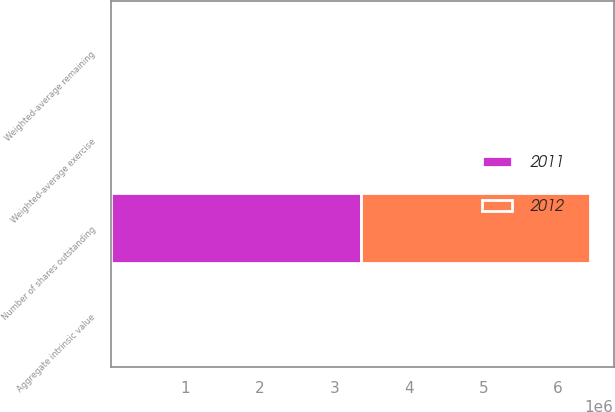Convert chart. <chart><loc_0><loc_0><loc_500><loc_500><stacked_bar_chart><ecel><fcel>Number of shares outstanding<fcel>Weighted-average exercise<fcel>Weighted-average remaining<fcel>Aggregate intrinsic value<nl><fcel>2012<fcel>3.07032e+06<fcel>41.98<fcel>5.7<fcel>29740<nl><fcel>2011<fcel>3.35458e+06<fcel>33.3<fcel>5.55<fcel>35173<nl></chart> 